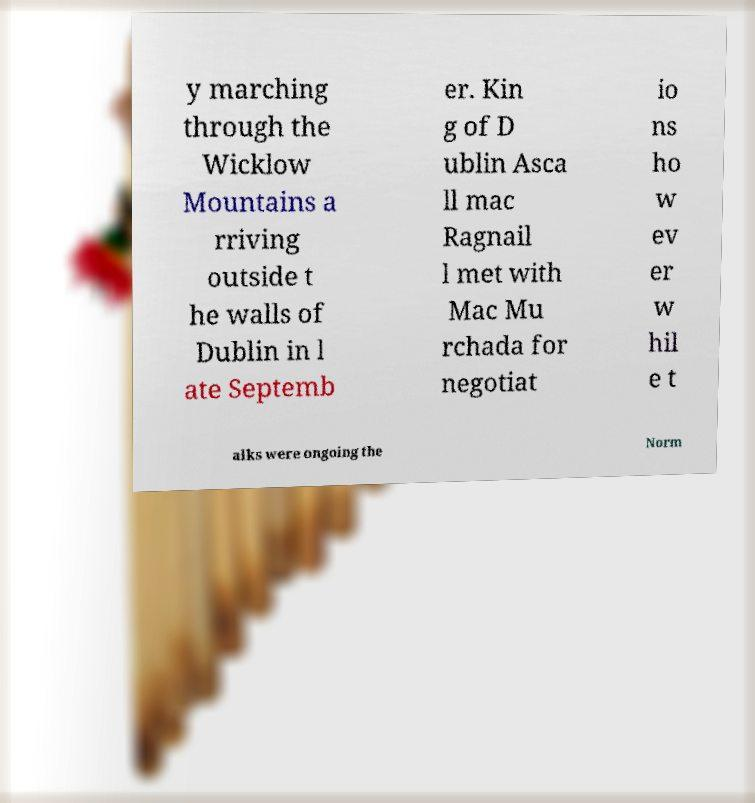Could you assist in decoding the text presented in this image and type it out clearly? y marching through the Wicklow Mountains a rriving outside t he walls of Dublin in l ate Septemb er. Kin g of D ublin Asca ll mac Ragnail l met with Mac Mu rchada for negotiat io ns ho w ev er w hil e t alks were ongoing the Norm 